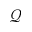<formula> <loc_0><loc_0><loc_500><loc_500>\mathcal { Q }</formula> 